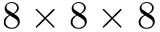<formula> <loc_0><loc_0><loc_500><loc_500>8 \times 8 \times 8</formula> 